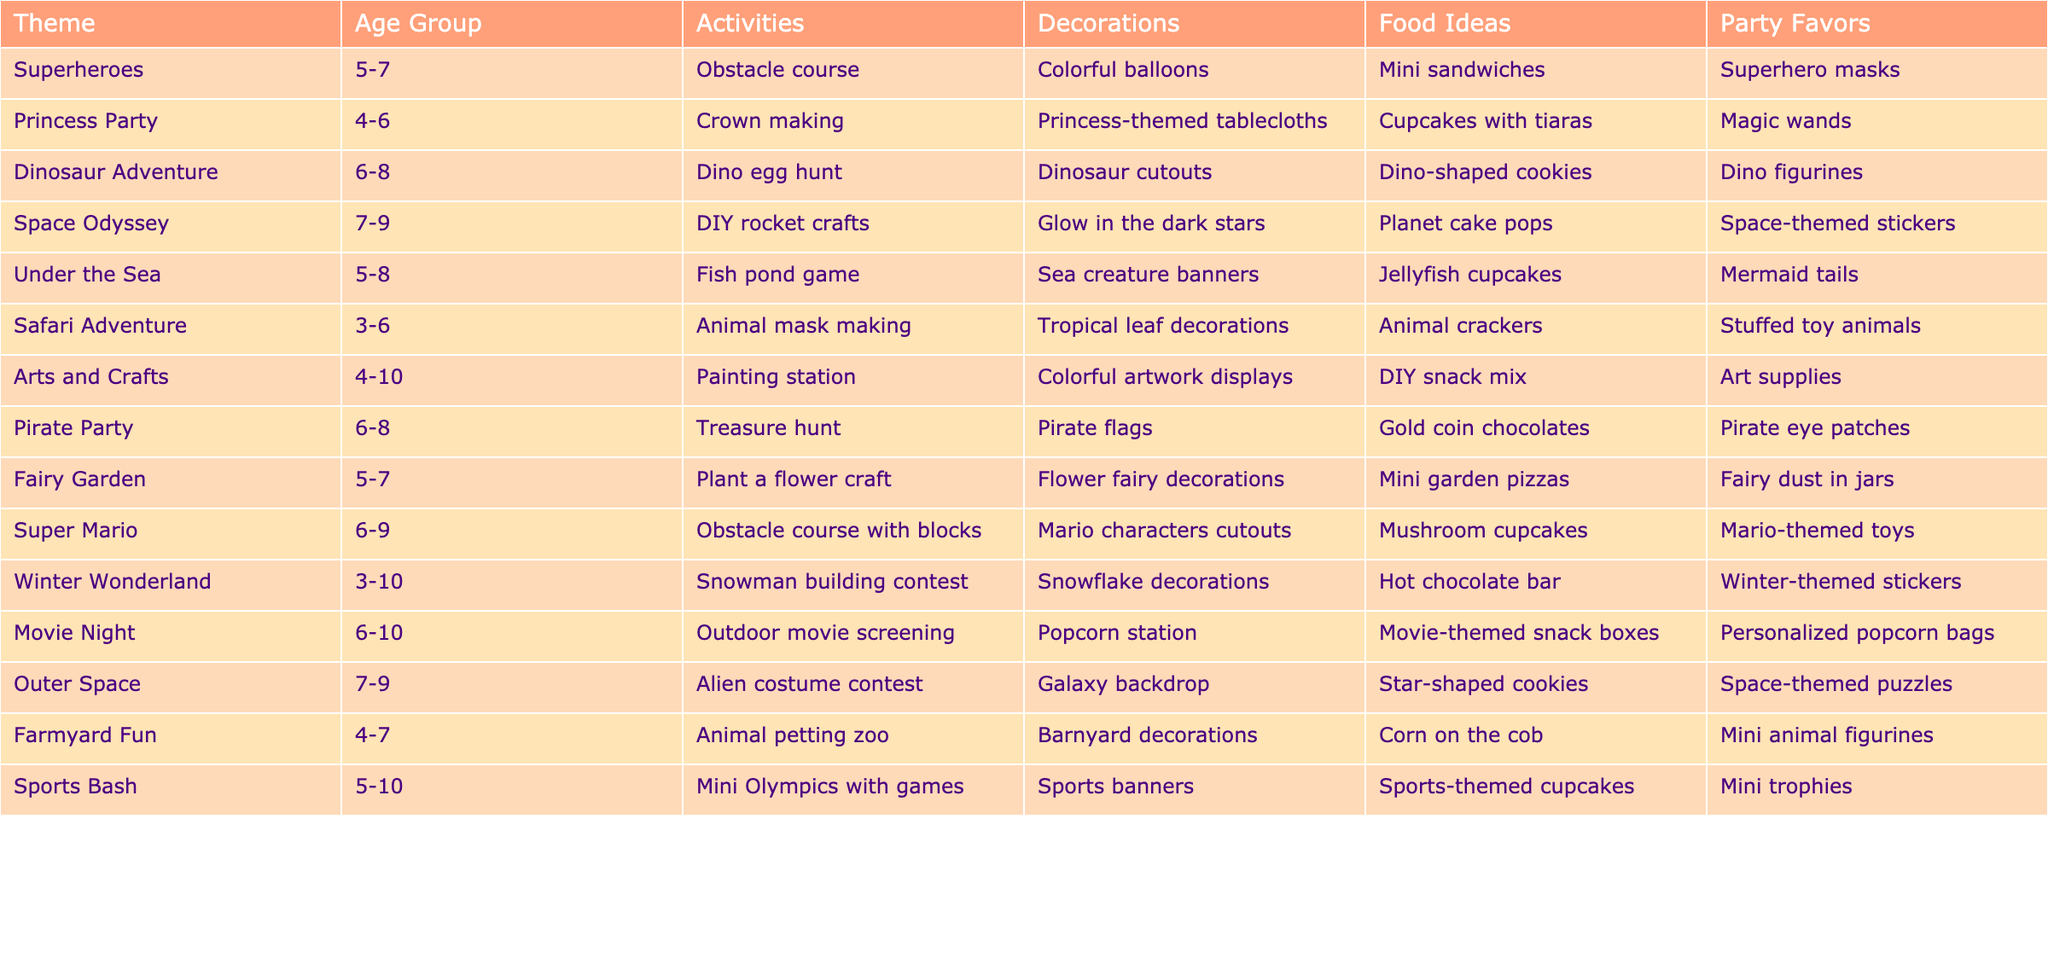What is the theme for 5 to 7-year-olds? The table lists several themes suitable for 5 to 7-year-olds, including Superheroes, Under the Sea, Fairy Garden, and Farmyard Fun.
Answer: Superheroes Which theme has activities related to the ocean? The Under the Sea theme includes activities like the fish pond game. This involves ocean-related elements.
Answer: Under the Sea How many themes are suitable for the age group of 3 to 6 years? There are two themes listed for the age group of 3 to 6 years: Safari Adventure and Winter Wonderland.
Answer: 2 What activities are included in the Pirate Party? The activities listed for the Pirate Party include a treasure hunt.
Answer: Treasure hunt Which party theme includes DIY crafts? The Space Odyssey, Arts and Crafts, and Super Mario themes all include DIY crafts such as DIY rocket crafts and painting stations.
Answer: Space Odyssey, Arts and Crafts, Super Mario What is the food idea for the Dinosaur Adventure? The food idea for the Dinosaur Adventure theme is dino-shaped cookies.
Answer: Dino-shaped cookies Is there a theme that has both sports and crafts? No, there is no single theme that combines sports activities and crafts. Each listed theme focuses on either one or the other.
Answer: No Which party theme has the oldest recommended age group? The theme with the oldest recommended age group is the Sports Bash, which is suitable for children aged 5 to 10 years old.
Answer: Sports Bash How many party favors are listed for the Winter Wonderland theme? The Winter Wonderland theme includes one type of party favor: winter-themed stickers.
Answer: 1 Are any themes listed that include food ideas in the shape of animals? Yes, the Safari Adventure theme includes animal crackers as a food idea, which fits the criteria of being in the shape of animals.
Answer: Yes Which theme has the most varied age group? The Arts and Crafts theme has the widest age range, being suitable for ages 4 to 10.
Answer: Arts and Crafts What do all the party themes have in common regarding food ideas? All party themes provide unique food ideas that creatively align with their respective themes.
Answer: Creativity in food ideas How many themes feature an obstacle course in their activities? There are two themes featuring an obstacle course: Superheroes and Super Mario.
Answer: 2 Which party theme includes a movie screening as an activity? The Movie Night theme includes an outdoor movie screening as one of its activities.
Answer: Movie Night What are the party favors for the Fairy Garden theme? The party favors for the Fairy Garden theme are fairy dust in jars.
Answer: Fairy dust in jars Which two themes have a combination of crafting and food related to their theme? The Fairy Garden and Pirate Party themes both include crafting activities and food ideas that relate to their themes.
Answer: Fairy Garden, Pirate Party 